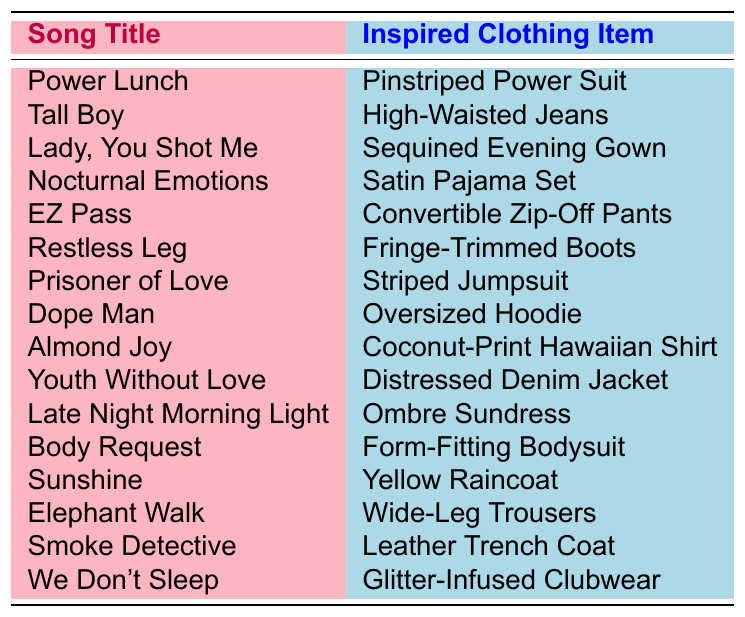What song inspired the design of the Sequined Evening Gown? The table lists the song titles alongside the inspired clothing items. By looking at the row for "Lady, You Shot Me," we can see that it inspired the Sequined Evening Gown.
Answer: Lady, You Shot Me Which inspired clothing item corresponds to the song "Sunshine"? By checking the table, we find the song "Sunshine" is linked to the Yellow Raincoat in the inspired items.
Answer: Yellow Raincoat Are there any clothing items inspired by songs that suggest comfort? Comfort-related clothing can include items like loungewear or relaxed styles. Upon reviewing, the Satin Pajama Set inspired by "Nocturnal Emotions" and the Oversized Hoodie from "Dope Man" suggest comfort.
Answer: Yes How many clothing items listed in the table are categorized as casual wear? Casual wear includes High-Waisted Jeans, Oversized Hoodie, and Distressed Denim Jacket. Counting these, we find there are 3 items.
Answer: 3 What is the difference between the number of evening wear items and casual wear items in this table? The evening wear items are Sequined Evening Gown and Ombre Sundress, adding up to 2 items. Casual wear items, as previously identified, total 3. The difference is 3 - 2 = 1.
Answer: 1 Which song title and inspired clothing item have the most vibrant and lively connotation? A lively connotation is implied by "Almond Joy," inspiring a Coconut-Print Hawaiian Shirt, which suggests a tropical and carefree vibe.
Answer: Almond Joy and Coconut-Print Hawaiian Shirt Is there a song title that corresponds to a clothing item with fringe detailing? Yes, "Restless Leg" corresponds to Fringe-Trimmed Boots, indicating this detailing.
Answer: Yes What is the relationship between "Smoke Detective" and its inspired clothing item? The song "Smoke Detective" is related to the inspired item, which is a Leather Trench Coat, often associated with dramatic and stylish outerwear that suggests mystery or intrigue.
Answer: Leather Trench Coat If I wanted to create a collection based on items that provide a retro feel, which items would fit? The Pinstriped Power Suit and the Striped Jumpsuit carry retro vibes. There are two items that embody this aesthetic.
Answer: 2 items How many song titles include the word 'night'? The songs "Nocturnal Emotions" and "Late Night Morning Light" include 'night.' Counting these, we find 2 titles.
Answer: 2 